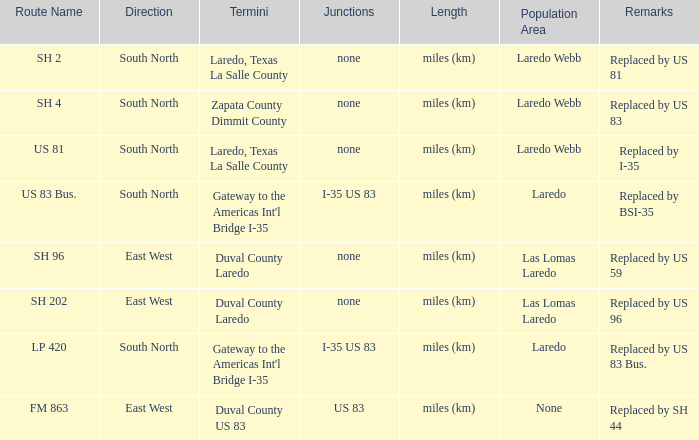What unit of length is being used for the route with "replaced by us 81" in their remarks section? Miles (km). 